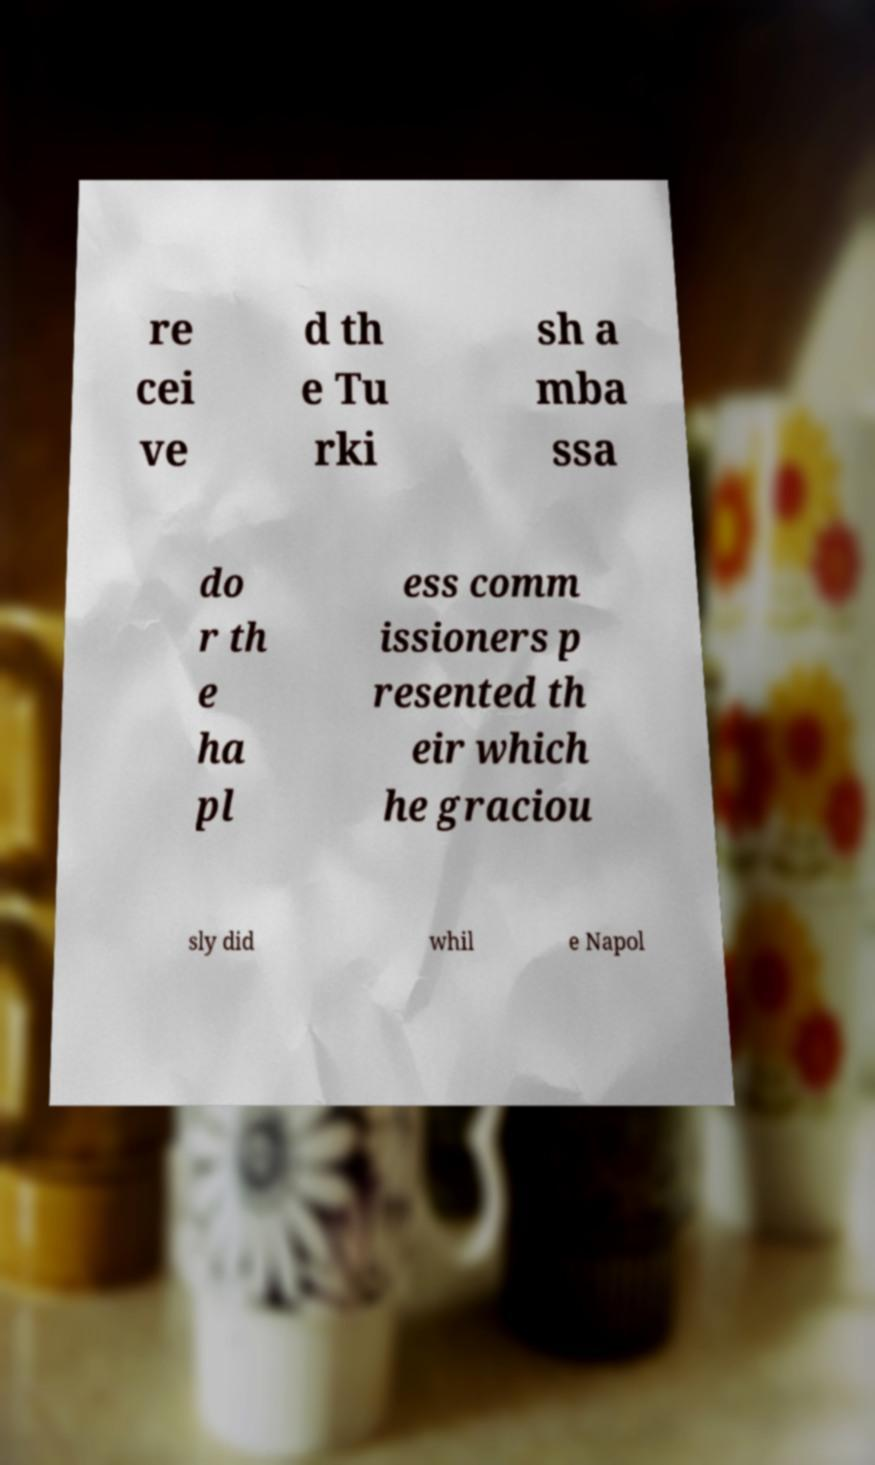Could you extract and type out the text from this image? re cei ve d th e Tu rki sh a mba ssa do r th e ha pl ess comm issioners p resented th eir which he graciou sly did whil e Napol 